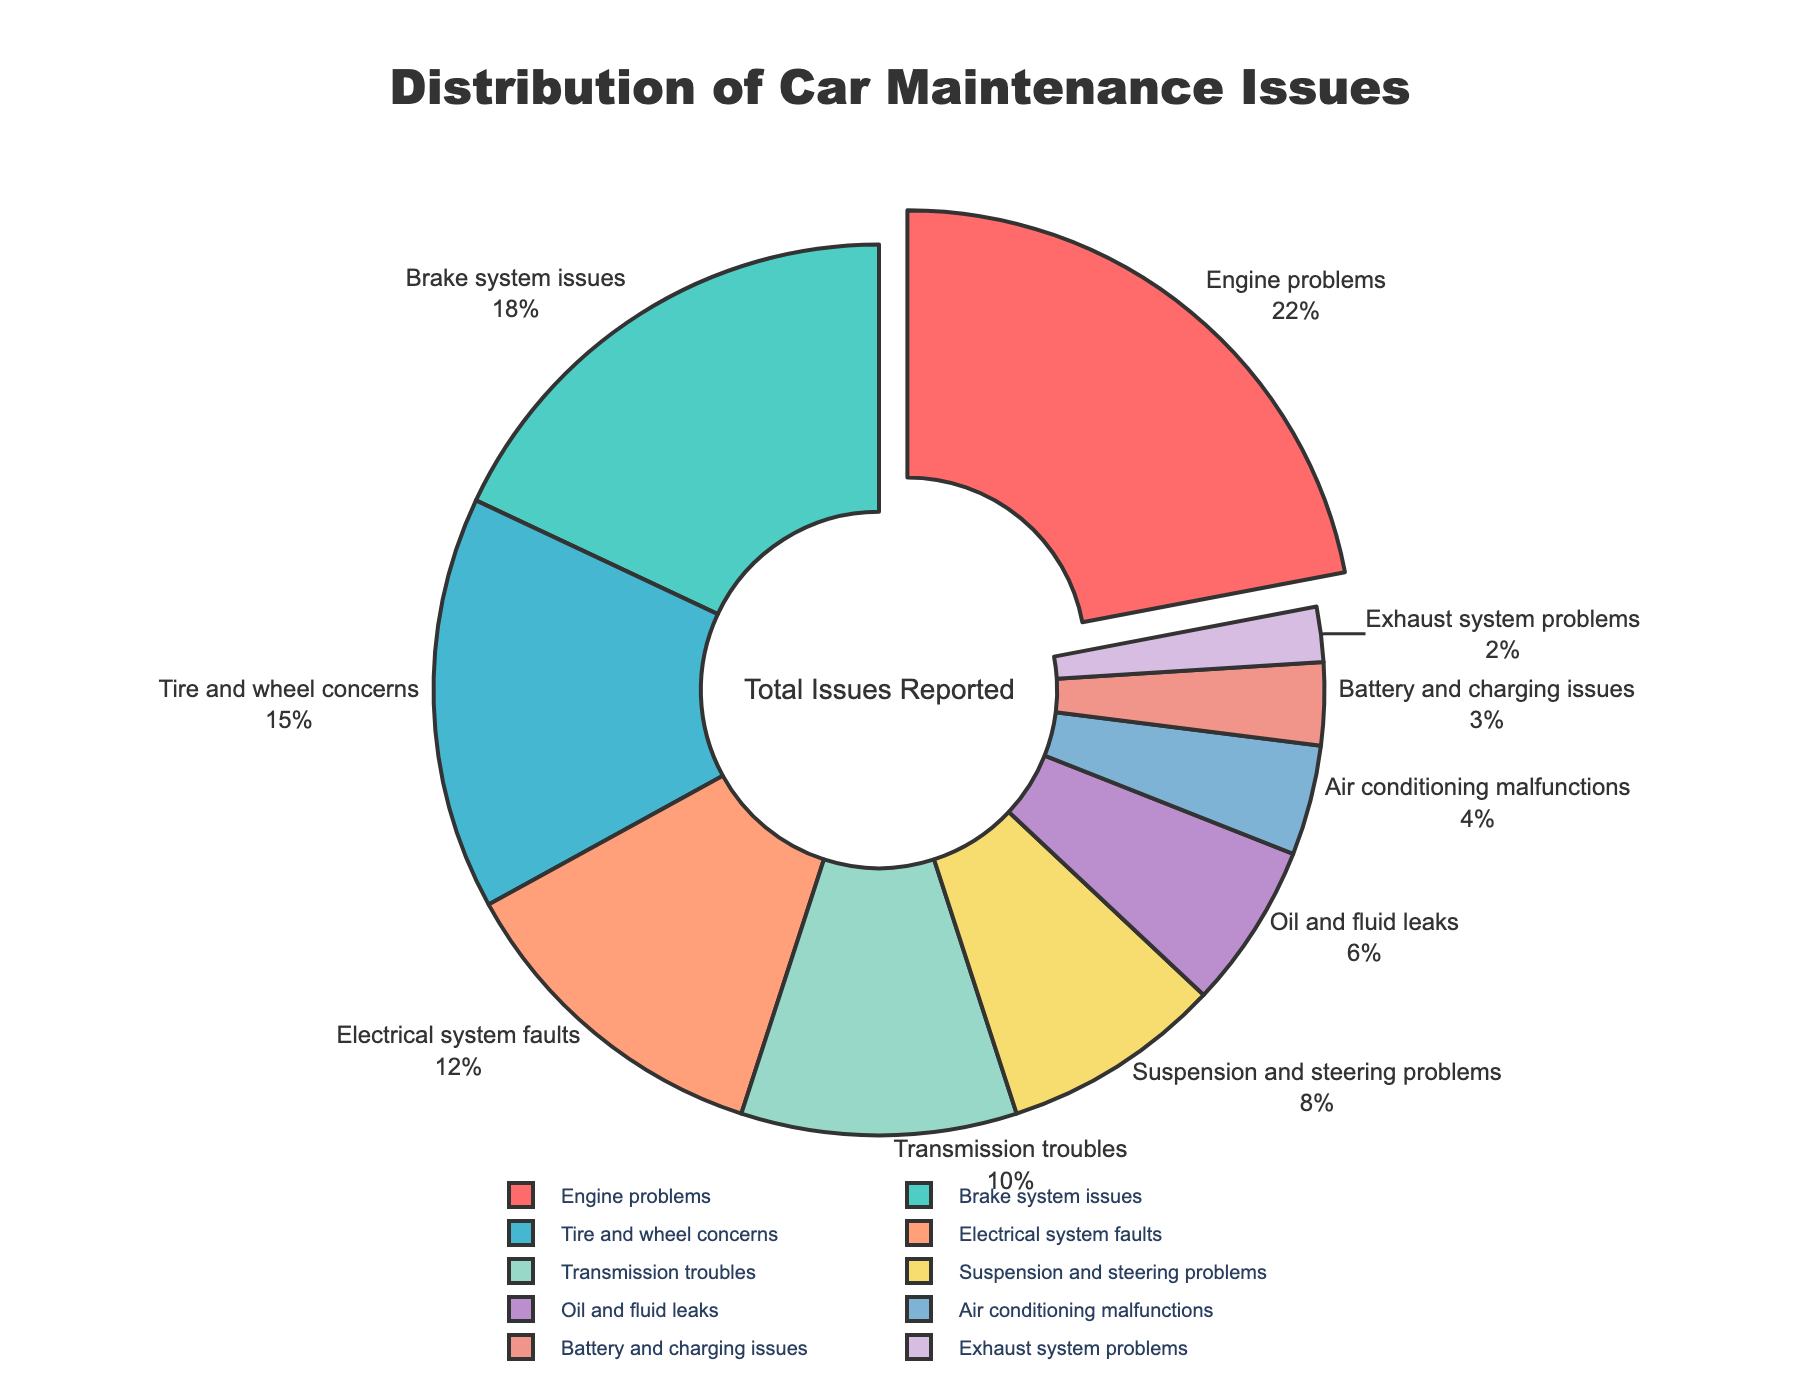What's the most common car maintenance issue reported by users? The pie chart shows the distribution of car maintenance issues by percentages. The largest segment represents the most common issue.
Answer: Engine problems Which two categories together account for more than one-third of the reported issues? Adding up the percentages of issues, Engine problems (22%) and Brake system issues (18%) together make 40%, which is more than one-third (33.33%).
Answer: Engine problems and Brake system issues What's the least common car maintenance issue reported by users? The smallest segment of the pie chart represents the least common issue, which is the one with the smallest percentage.
Answer: Exhaust system problems How many categories represent less than 10% of the reported issues each? Identify the segments with percentages less than 10%. These are Transmission troubles (10%), Suspension and steering problems (8%), Oil and fluid leaks (6%), Air conditioning malfunctions (4%), Battery and charging issues (3%), and Exhaust system problems (2%). Count these categories.
Answer: 6 Is the percentage of Electrical system faults greater than the percentage of Tire and wheel concerns? Compare the percentages for Electrical system faults (12%) and Tire and wheel concerns (15%) from the chart.
Answer: No What is the combined percentage of Suspension and steering problems, and Air conditioning malfunctions? Add the percentages for Suspension and steering problems (8%) and Air conditioning malfunctions (4%).
Answer: 12% Are Oil and fluid leaks more common than Battery and charging issues? Compare the percentages for Oil and fluid leaks (6%) and Battery and charging issues (3%).
Answer: Yes What’s the difference in percentage between Transmission troubles and Brake system issues? Subtract the percentage for Brake system issues (18%) from that for Transmission troubles (10%).
Answer: -8% Which issue has the segment color blue? The pie chart segment representing a certain issue is colored blue. Determine which issue this color corresponds to visually.
Answer: Tire and wheel concerns 